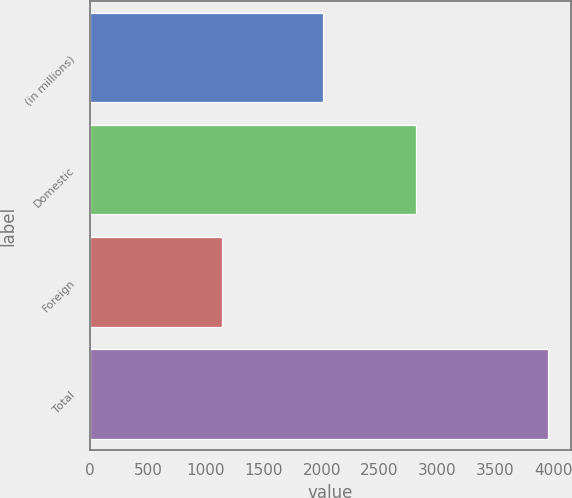Convert chart. <chart><loc_0><loc_0><loc_500><loc_500><bar_chart><fcel>(in millions)<fcel>Domestic<fcel>Foreign<fcel>Total<nl><fcel>2013<fcel>2814<fcel>1140<fcel>3954<nl></chart> 